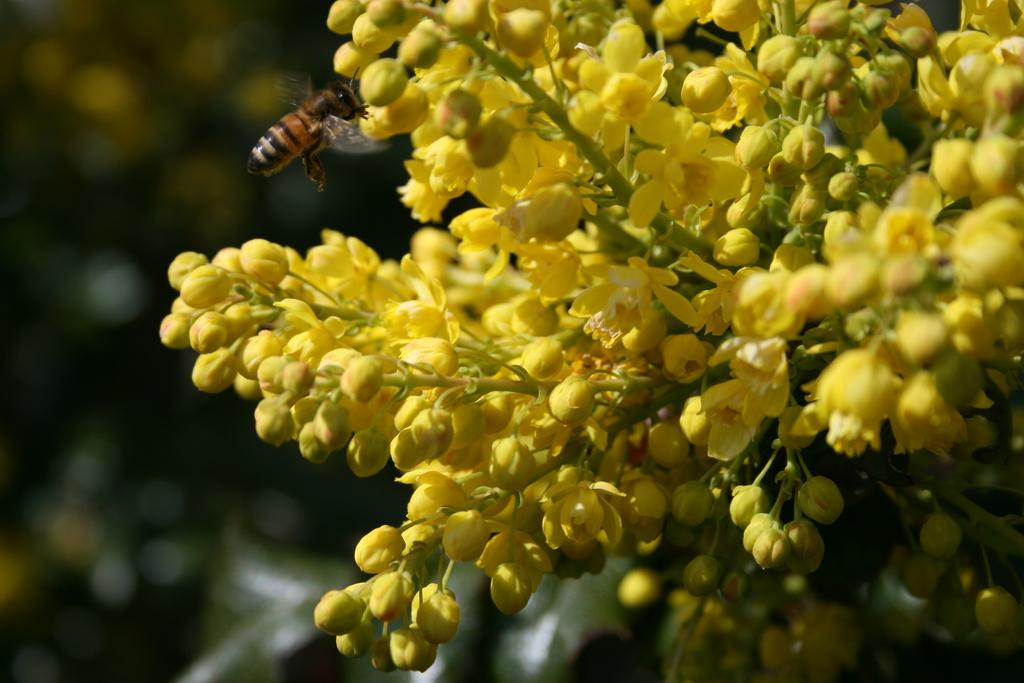What type of flowers are present in the image? There are yellow flowers in the image. Are there any other living organisms visible in the image? Yes, there is a honey bee beside the flowers. How is the background of the flowers depicted in the image? The background of the flowers is blurred. What type of shop can be seen in the background of the image? There is no shop present in the image; it features yellow flowers and a honey bee. 